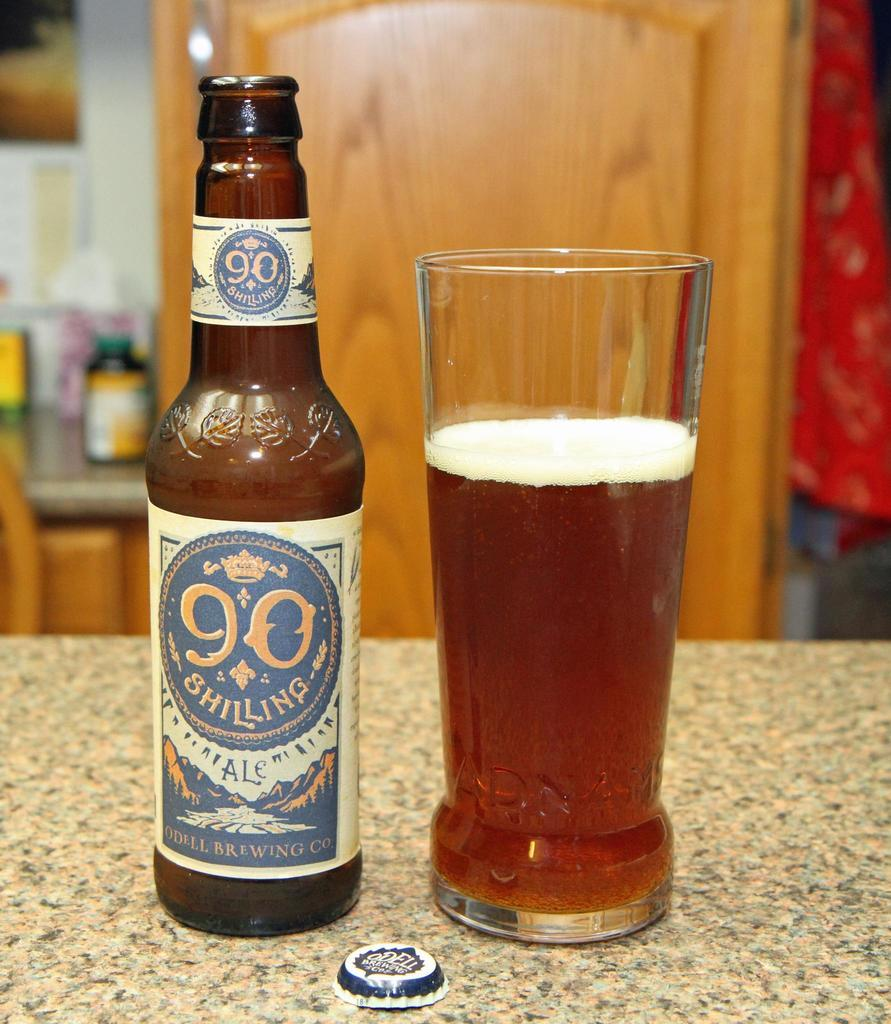<image>
Write a terse but informative summary of the picture. A 90 Shilling branded ale bottle sits next to a glass. 